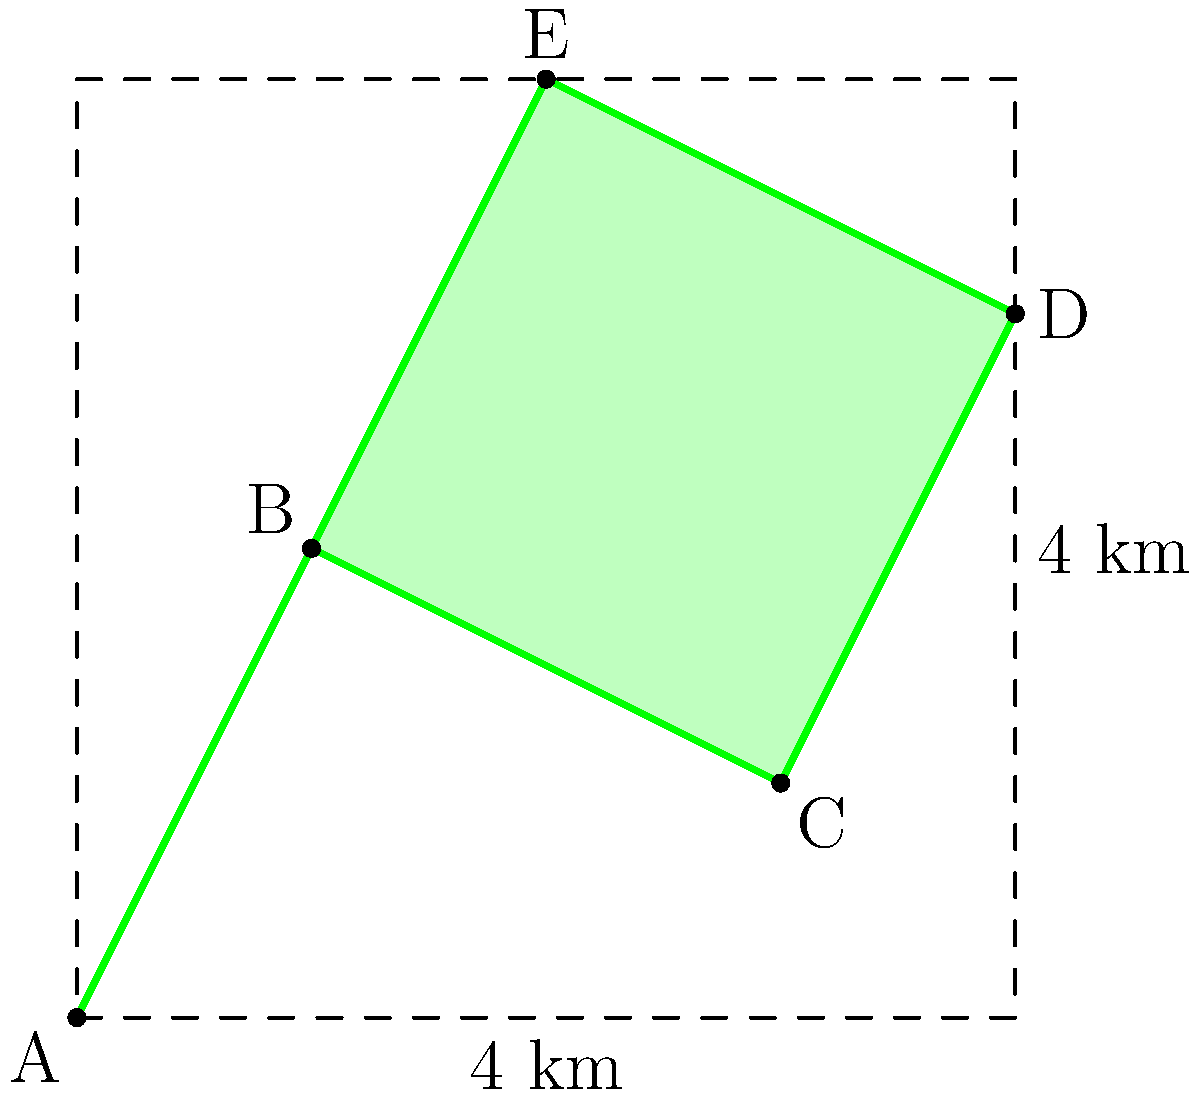As a cafe owner providing refreshments for a hiking group, you've been asked to estimate the area of a new irregular-shaped trail on a map. The trail is represented by the green area in the diagram, where each square represents 1 square kilometer. Using the trapezoidal method, calculate the approximate area of the trail in square kilometers. Round your answer to the nearest tenth. To estimate the area of the irregular-shaped trail using the trapezoidal method, we'll follow these steps:

1) Divide the shape into trapezoids by drawing vertical lines from each vertex to the x-axis.

2) Calculate the area of each trapezoid using the formula: $A = \frac{1}{2}(b_1 + b_2)h$, where $b_1$ and $b_2$ are the parallel sides and $h$ is the height.

3) Sum the areas of all trapezoids.

Let's calculate:

Trapezoid 1 (between x = 0 and x = 1):
$A_1 = \frac{1}{2}(0 + 2) \cdot 1 = 1$ sq km

Trapezoid 2 (between x = 1 and x = 3):
$A_2 = \frac{1}{2}(2 + 1) \cdot 2 = 3$ sq km

Trapezoid 3 (between x = 3 and x = 4):
$A_3 = \frac{1}{2}(1 + 3) \cdot 1 = 2$ sq km

Total area: $A_{total} = A_1 + A_2 + A_3 = 1 + 3 + 2 = 6$ sq km

Rounding to the nearest tenth: 6.0 sq km
Answer: 6.0 sq km 